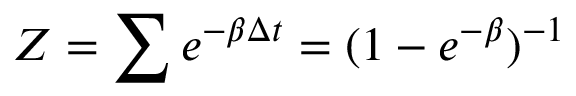Convert formula to latex. <formula><loc_0><loc_0><loc_500><loc_500>Z = \sum e ^ { - \beta \Delta t } = ( 1 - e ^ { - \beta } ) ^ { - 1 }</formula> 